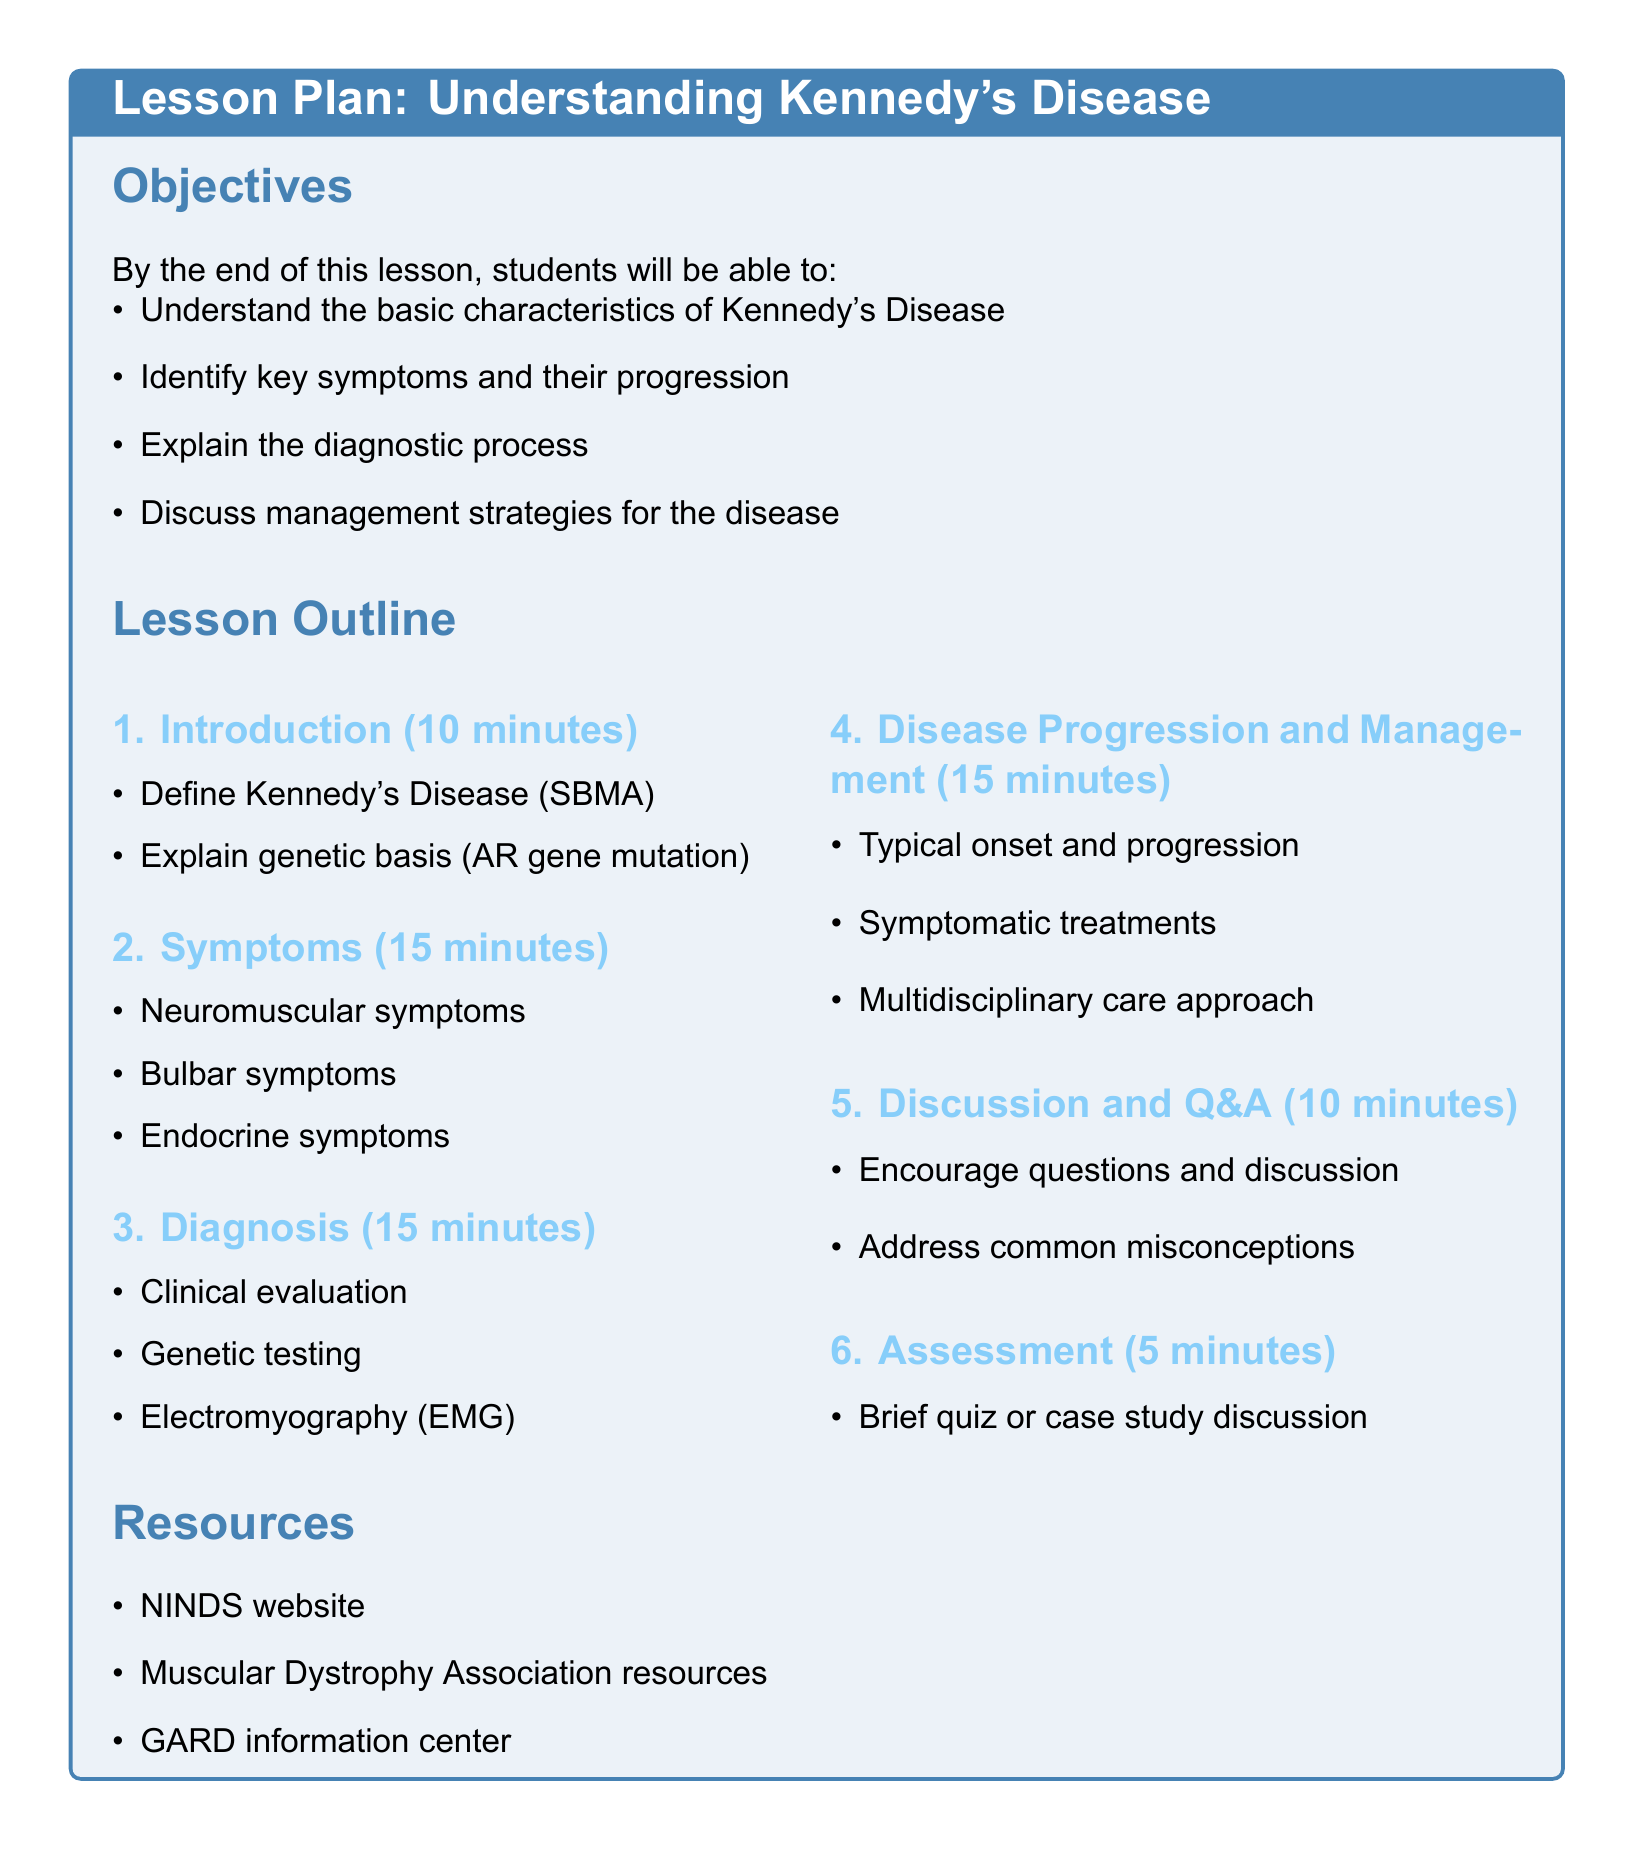what is Kennedy's Disease also known as? The lesson plan defines Kennedy's Disease as SBMA.
Answer: SBMA what gene mutation is associated with Kennedy's Disease? The genetic basis of Kennedy's Disease is explained in the introduction section.
Answer: AR gene mutation how long is the discussion and Q&A section? The lesson plan specifies the duration of this section.
Answer: 10 minutes what are three types of symptoms mentioned? Symptoms are categorized in the lesson plan.
Answer: Neuromuscular symptoms, Bulbar symptoms, Endocrine symptoms what diagnostic tool is used for assessing muscle activity? The diagnostic process mentions a specific test for assessing muscle activity.
Answer: Electromyography (EMG) how many minutes are allocated for the assessment? The document specifies the duration of this section.
Answer: 5 minutes what is one resource mentioned for further information? Available resources are listed at the end of the lesson plan.
Answer: NINDS website what approach is recommended for managing Kennedy's Disease? The management strategies section discusses a specific approach.
Answer: Multidisciplinary care approach what should be encouraged during the discussion and Q&A section? The lesson plan suggests a specific activity for this section.
Answer: Questions and discussion 